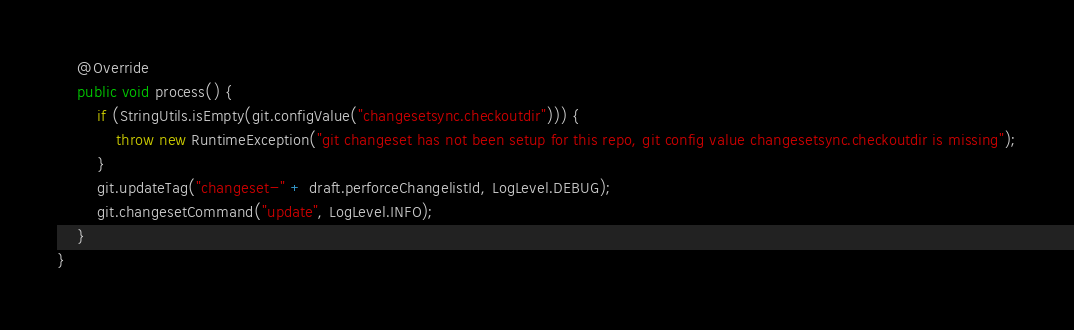Convert code to text. <code><loc_0><loc_0><loc_500><loc_500><_Java_>    @Override
    public void process() {
        if (StringUtils.isEmpty(git.configValue("changesetsync.checkoutdir"))) {
            throw new RuntimeException("git changeset has not been setup for this repo, git config value changesetsync.checkoutdir is missing");
        }
        git.updateTag("changeset-" + draft.perforceChangelistId, LogLevel.DEBUG);
        git.changesetCommand("update", LogLevel.INFO);
    }
}
</code> 